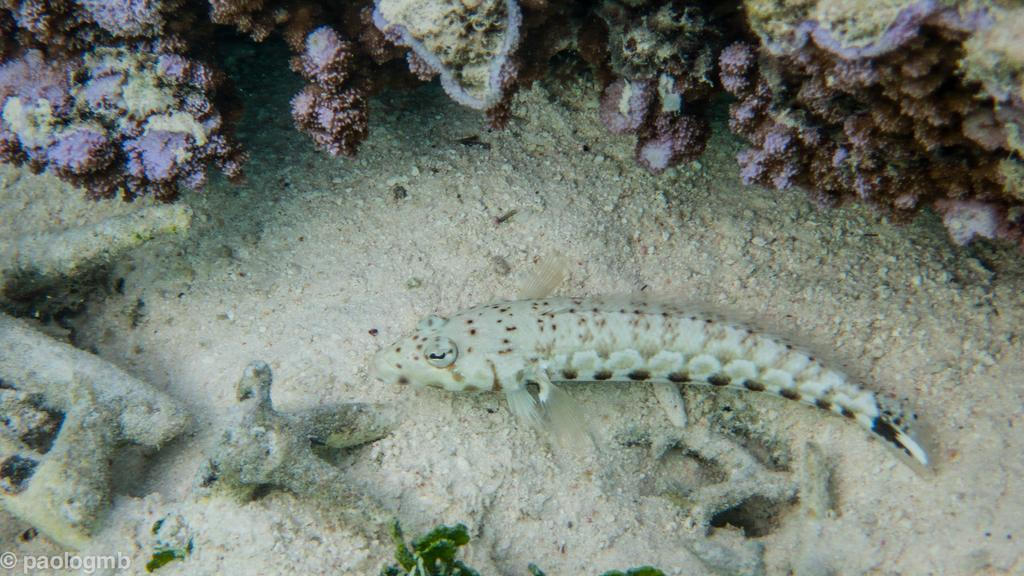What type of animal can be seen in the image? There is a fish in the image. What type of terrain is visible in the image? There is sand visible in the image. What other living organisms can be seen at the bottom of the sea in the image? There are other plant species at the bottom of the sea in the image. What type of locket is the fish wearing in the image? There is no locket present in the image, as fish do not wear jewelry. 